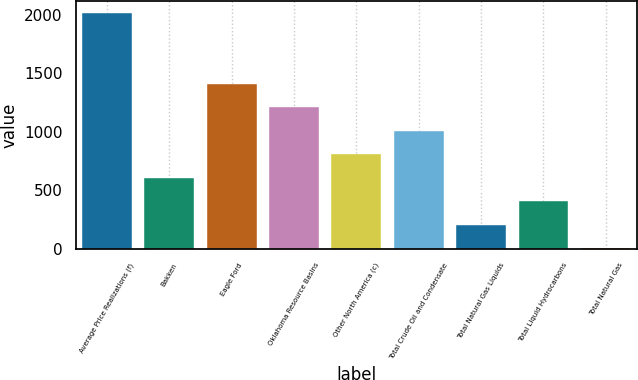Convert chart. <chart><loc_0><loc_0><loc_500><loc_500><bar_chart><fcel>Average Price Realizations (f)<fcel>Bakken<fcel>Eagle Ford<fcel>Oklahoma Resource Basins<fcel>Other North America (c)<fcel>Total Crude Oil and Condensate<fcel>Total Natural Gas Liquids<fcel>Total Liquid Hydrocarbons<fcel>Total Natural Gas<nl><fcel>2013<fcel>606.6<fcel>1410.28<fcel>1209.36<fcel>807.52<fcel>1008.44<fcel>204.76<fcel>405.68<fcel>3.84<nl></chart> 